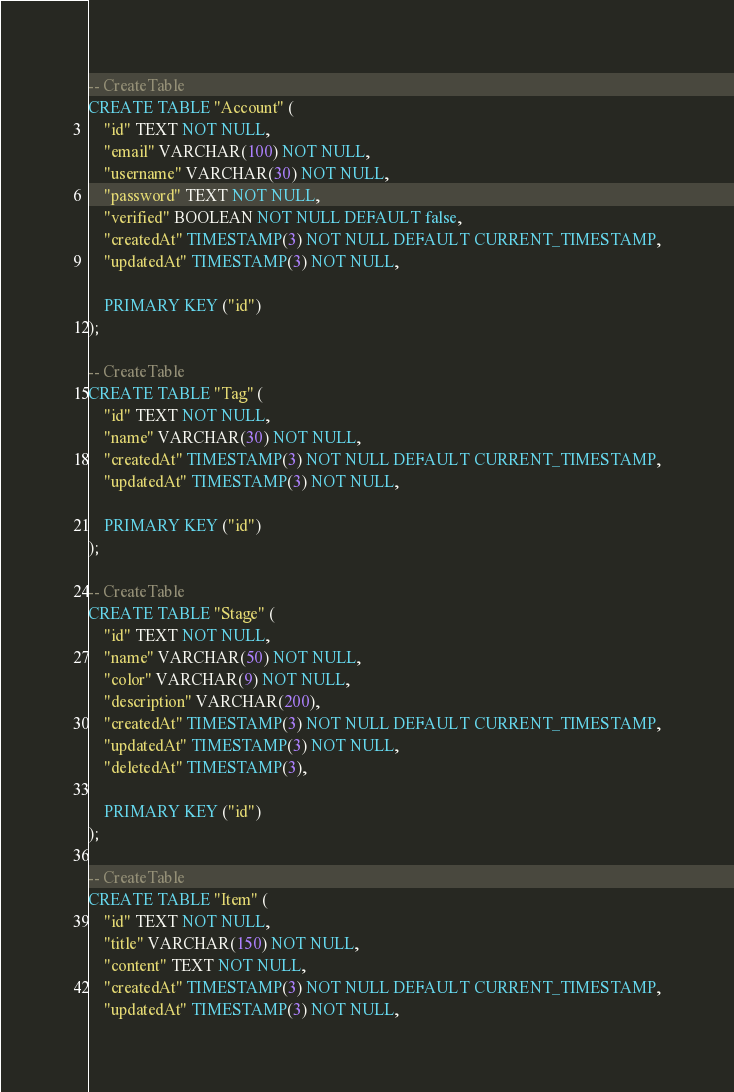<code> <loc_0><loc_0><loc_500><loc_500><_SQL_>-- CreateTable
CREATE TABLE "Account" (
    "id" TEXT NOT NULL,
    "email" VARCHAR(100) NOT NULL,
    "username" VARCHAR(30) NOT NULL,
    "password" TEXT NOT NULL,
    "verified" BOOLEAN NOT NULL DEFAULT false,
    "createdAt" TIMESTAMP(3) NOT NULL DEFAULT CURRENT_TIMESTAMP,
    "updatedAt" TIMESTAMP(3) NOT NULL,

    PRIMARY KEY ("id")
);

-- CreateTable
CREATE TABLE "Tag" (
    "id" TEXT NOT NULL,
    "name" VARCHAR(30) NOT NULL,
    "createdAt" TIMESTAMP(3) NOT NULL DEFAULT CURRENT_TIMESTAMP,
    "updatedAt" TIMESTAMP(3) NOT NULL,

    PRIMARY KEY ("id")
);

-- CreateTable
CREATE TABLE "Stage" (
    "id" TEXT NOT NULL,
    "name" VARCHAR(50) NOT NULL,
    "color" VARCHAR(9) NOT NULL,
    "description" VARCHAR(200),
    "createdAt" TIMESTAMP(3) NOT NULL DEFAULT CURRENT_TIMESTAMP,
    "updatedAt" TIMESTAMP(3) NOT NULL,
    "deletedAt" TIMESTAMP(3),

    PRIMARY KEY ("id")
);

-- CreateTable
CREATE TABLE "Item" (
    "id" TEXT NOT NULL,
    "title" VARCHAR(150) NOT NULL,
    "content" TEXT NOT NULL,
    "createdAt" TIMESTAMP(3) NOT NULL DEFAULT CURRENT_TIMESTAMP,
    "updatedAt" TIMESTAMP(3) NOT NULL,</code> 